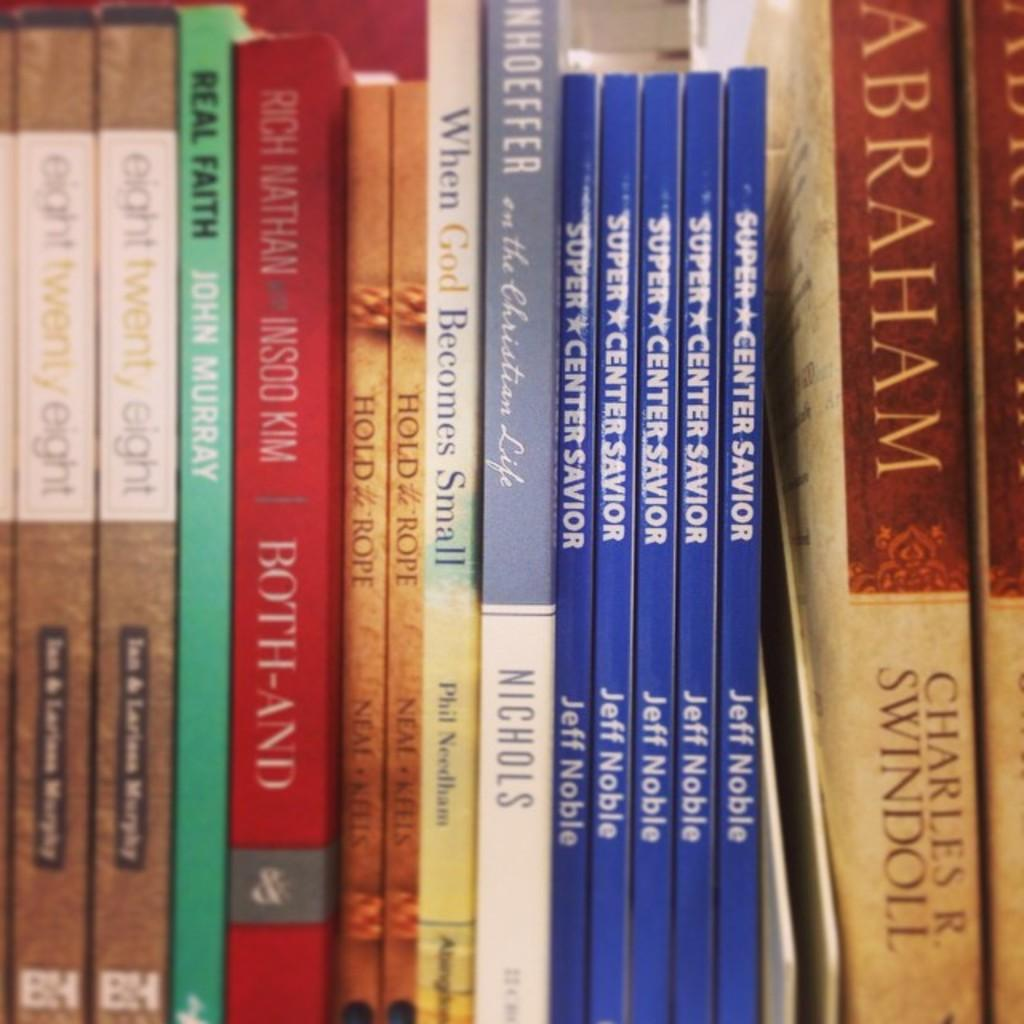<image>
Create a compact narrative representing the image presented. nine paperbook books on a shelf about religon 